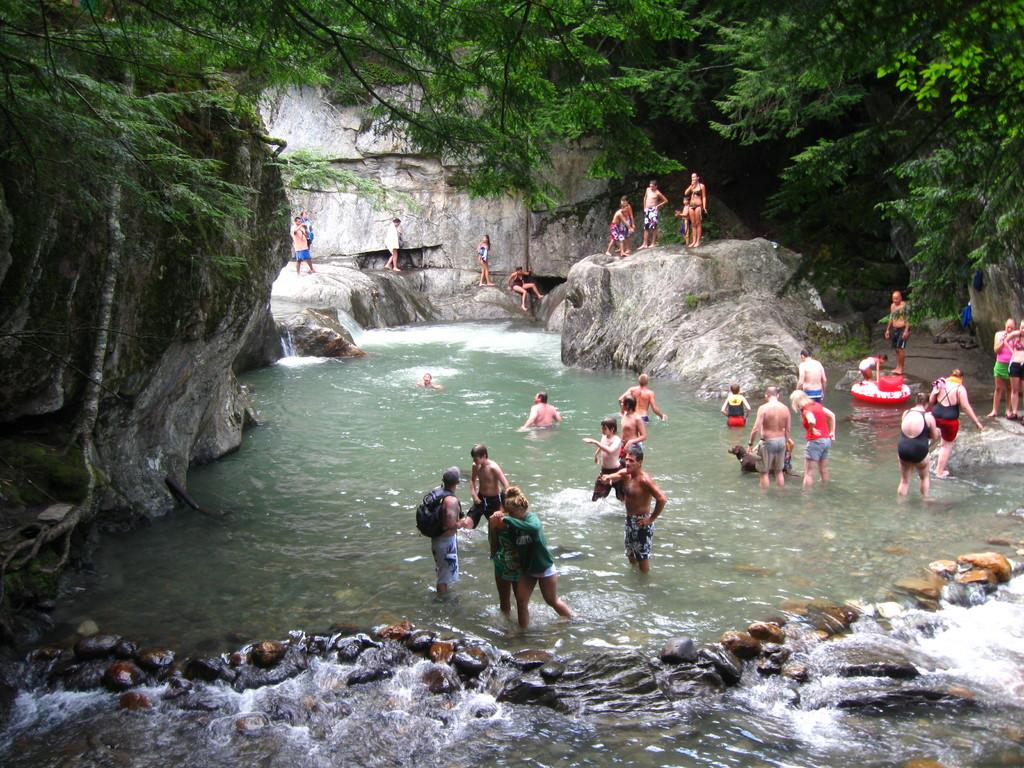What are the people in the image doing? The people in the image are standing in the water. Are there any rocks visible in the image? Yes, some people are standing on rocks, and there are rocks in the background of the image. What can be seen in the background of the image? There are trees and stones in the background of the image. How does the person in the image help with addition? There is no person in the image performing addition or any mathematical task. 